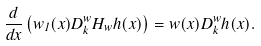<formula> <loc_0><loc_0><loc_500><loc_500>\frac { d } { d x } \left ( w _ { 1 } ( x ) D _ { k } ^ { w } H _ { w } h ( x ) \right ) = w ( x ) D _ { k } ^ { w } h ( x ) .</formula> 